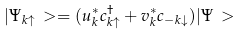<formula> <loc_0><loc_0><loc_500><loc_500>| \Psi _ { k \uparrow } \, > = ( u _ { k } ^ { * } c _ { k \uparrow } ^ { \dagger } + v _ { k } ^ { * } c _ { - k \downarrow } ) | \Psi \, ></formula> 